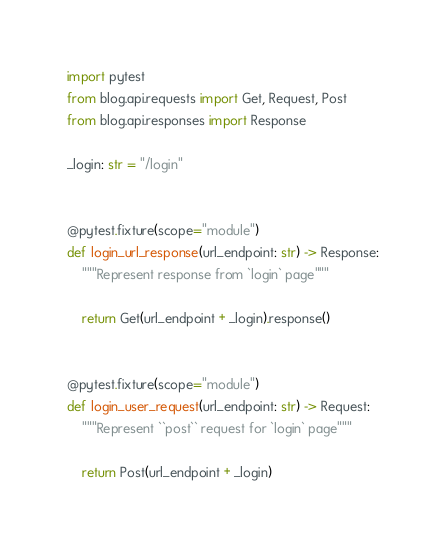Convert code to text. <code><loc_0><loc_0><loc_500><loc_500><_Python_>import pytest
from blog.api.requests import Get, Request, Post
from blog.api.responses import Response

_login: str = "/login"


@pytest.fixture(scope="module")
def login_url_response(url_endpoint: str) -> Response:
    """Represent response from `login` page"""

    return Get(url_endpoint + _login).response()


@pytest.fixture(scope="module")
def login_user_request(url_endpoint: str) -> Request:
    """Represent ``post`` request for `login` page"""

    return Post(url_endpoint + _login)
</code> 